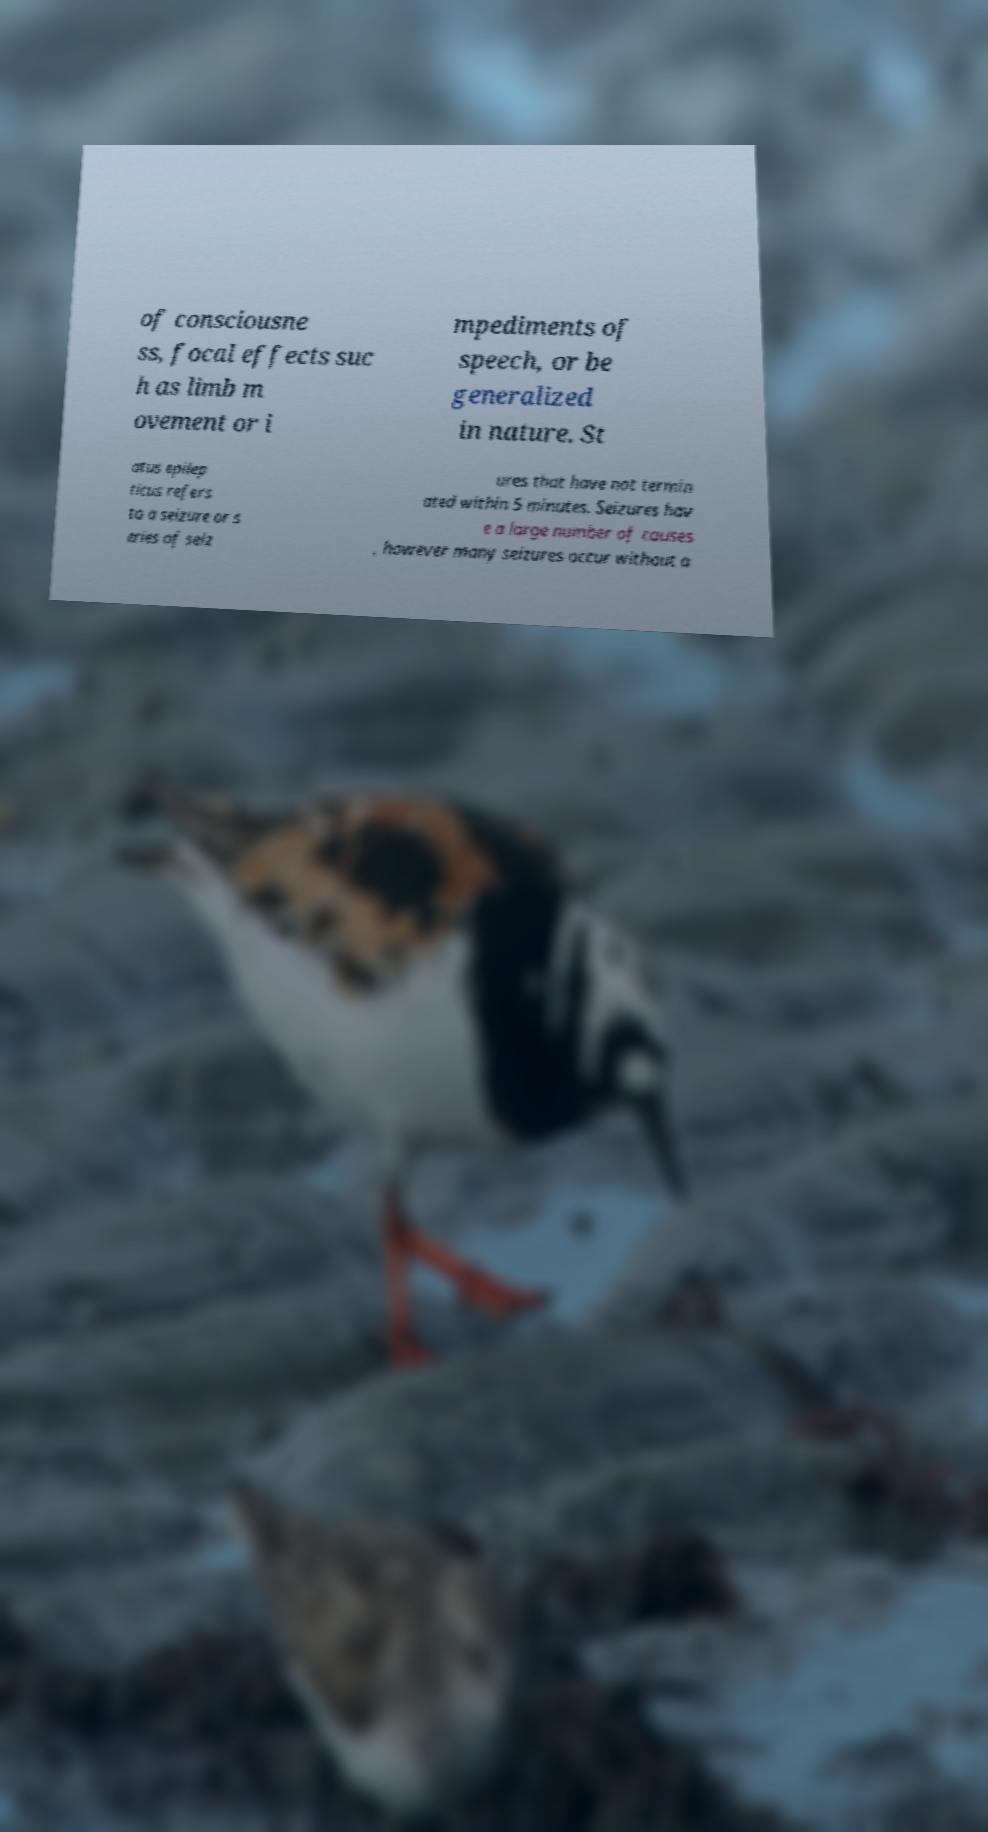Please identify and transcribe the text found in this image. of consciousne ss, focal effects suc h as limb m ovement or i mpediments of speech, or be generalized in nature. St atus epilep ticus refers to a seizure or s eries of seiz ures that have not termin ated within 5 minutes. Seizures hav e a large number of causes , however many seizures occur without a 